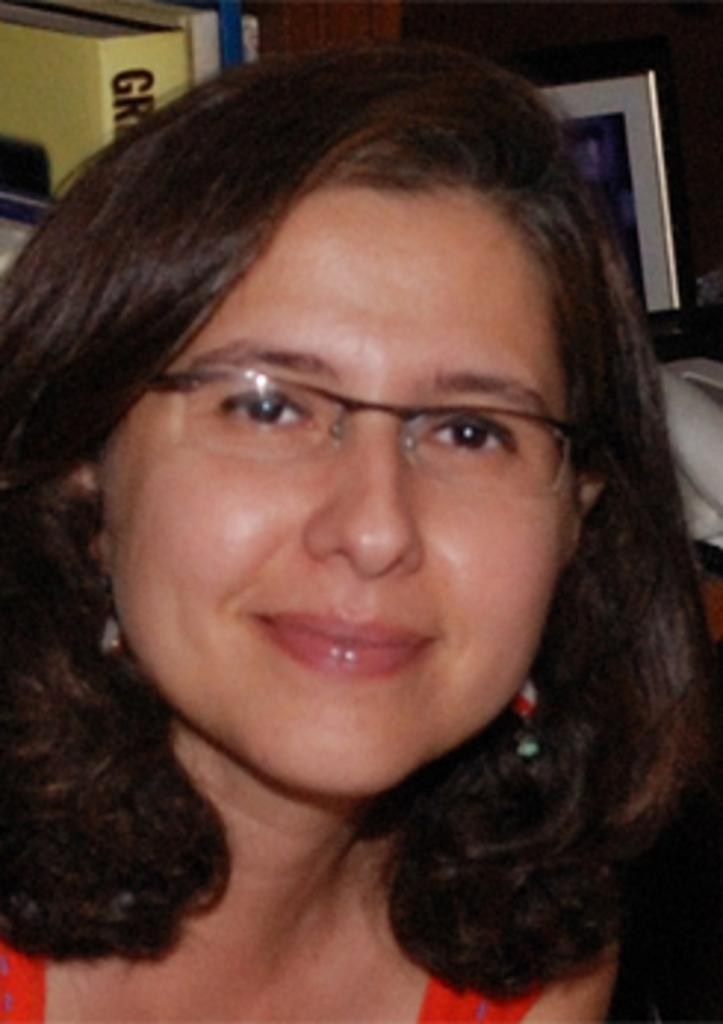Who or what is present in the image? There is a person in the image. What is the person wearing? The person is wearing a red dress. What can be seen in the background of the image? There is a frame and a yellow color object in the background of the image. What type of glass is being used to paint the iron in the image? There is no glass, paint, or iron present in the image. 